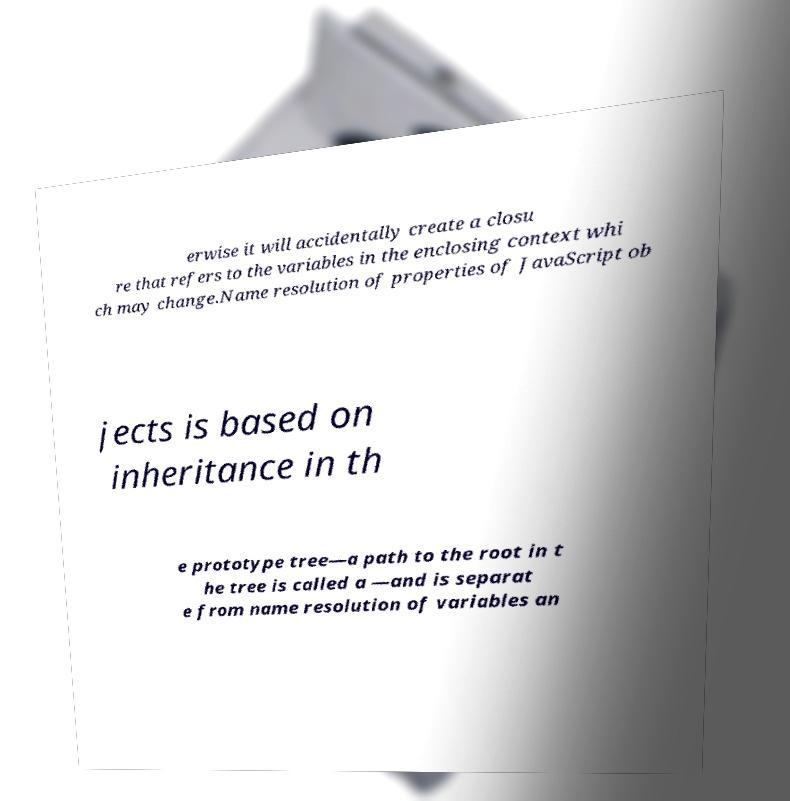I need the written content from this picture converted into text. Can you do that? Certainly! The text from the image reads as follows: '...otherwise it will accidentally create a closure that refers to the variables in the enclosing context which may change. Name resolution of properties of JavaScript objects is based on inheritance in the prototype tree—a path to the root in the tree is called a—and is separate from name resolution of variables an...'
Note: Some parts of the text are not fully visible in the image and might be incomplete. 